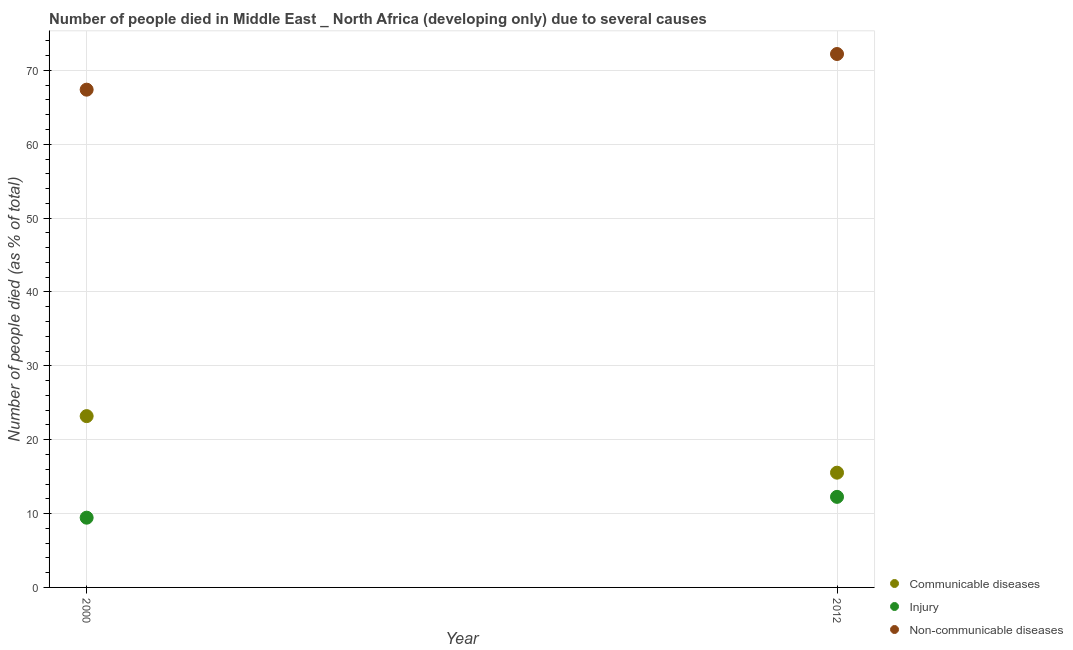How many different coloured dotlines are there?
Provide a short and direct response. 3. Is the number of dotlines equal to the number of legend labels?
Your response must be concise. Yes. What is the number of people who died of injury in 2000?
Provide a succinct answer. 9.44. Across all years, what is the maximum number of people who died of injury?
Ensure brevity in your answer.  12.26. Across all years, what is the minimum number of people who dies of non-communicable diseases?
Provide a short and direct response. 67.39. In which year was the number of people who dies of non-communicable diseases minimum?
Keep it short and to the point. 2000. What is the total number of people who died of communicable diseases in the graph?
Your response must be concise. 38.73. What is the difference between the number of people who dies of non-communicable diseases in 2000 and that in 2012?
Give a very brief answer. -4.83. What is the difference between the number of people who died of communicable diseases in 2012 and the number of people who dies of non-communicable diseases in 2000?
Give a very brief answer. -51.86. What is the average number of people who died of injury per year?
Ensure brevity in your answer.  10.85. In the year 2012, what is the difference between the number of people who dies of non-communicable diseases and number of people who died of injury?
Offer a very short reply. 59.96. In how many years, is the number of people who died of injury greater than 50 %?
Your response must be concise. 0. What is the ratio of the number of people who died of injury in 2000 to that in 2012?
Offer a very short reply. 0.77. Is it the case that in every year, the sum of the number of people who died of communicable diseases and number of people who died of injury is greater than the number of people who dies of non-communicable diseases?
Ensure brevity in your answer.  No. Does the number of people who dies of non-communicable diseases monotonically increase over the years?
Keep it short and to the point. Yes. Is the number of people who died of injury strictly less than the number of people who dies of non-communicable diseases over the years?
Provide a short and direct response. Yes. What is the difference between two consecutive major ticks on the Y-axis?
Offer a very short reply. 10. Does the graph contain any zero values?
Provide a short and direct response. No. Does the graph contain grids?
Keep it short and to the point. Yes. How many legend labels are there?
Provide a short and direct response. 3. What is the title of the graph?
Ensure brevity in your answer.  Number of people died in Middle East _ North Africa (developing only) due to several causes. Does "Agricultural Nitrous Oxide" appear as one of the legend labels in the graph?
Offer a terse response. No. What is the label or title of the Y-axis?
Your answer should be compact. Number of people died (as % of total). What is the Number of people died (as % of total) in Communicable diseases in 2000?
Keep it short and to the point. 23.19. What is the Number of people died (as % of total) in Injury in 2000?
Ensure brevity in your answer.  9.44. What is the Number of people died (as % of total) of Non-communicable diseases in 2000?
Provide a short and direct response. 67.39. What is the Number of people died (as % of total) in Communicable diseases in 2012?
Your answer should be compact. 15.54. What is the Number of people died (as % of total) in Injury in 2012?
Your answer should be compact. 12.26. What is the Number of people died (as % of total) of Non-communicable diseases in 2012?
Keep it short and to the point. 72.22. Across all years, what is the maximum Number of people died (as % of total) in Communicable diseases?
Offer a terse response. 23.19. Across all years, what is the maximum Number of people died (as % of total) in Injury?
Provide a succinct answer. 12.26. Across all years, what is the maximum Number of people died (as % of total) in Non-communicable diseases?
Your response must be concise. 72.22. Across all years, what is the minimum Number of people died (as % of total) of Communicable diseases?
Make the answer very short. 15.54. Across all years, what is the minimum Number of people died (as % of total) of Injury?
Offer a very short reply. 9.44. Across all years, what is the minimum Number of people died (as % of total) in Non-communicable diseases?
Provide a succinct answer. 67.39. What is the total Number of people died (as % of total) in Communicable diseases in the graph?
Give a very brief answer. 38.73. What is the total Number of people died (as % of total) in Injury in the graph?
Offer a very short reply. 21.7. What is the total Number of people died (as % of total) in Non-communicable diseases in the graph?
Your answer should be compact. 139.61. What is the difference between the Number of people died (as % of total) of Communicable diseases in 2000 and that in 2012?
Your answer should be compact. 7.66. What is the difference between the Number of people died (as % of total) in Injury in 2000 and that in 2012?
Ensure brevity in your answer.  -2.82. What is the difference between the Number of people died (as % of total) in Non-communicable diseases in 2000 and that in 2012?
Your response must be concise. -4.83. What is the difference between the Number of people died (as % of total) in Communicable diseases in 2000 and the Number of people died (as % of total) in Injury in 2012?
Your response must be concise. 10.93. What is the difference between the Number of people died (as % of total) of Communicable diseases in 2000 and the Number of people died (as % of total) of Non-communicable diseases in 2012?
Give a very brief answer. -49.03. What is the difference between the Number of people died (as % of total) in Injury in 2000 and the Number of people died (as % of total) in Non-communicable diseases in 2012?
Offer a terse response. -62.78. What is the average Number of people died (as % of total) of Communicable diseases per year?
Keep it short and to the point. 19.36. What is the average Number of people died (as % of total) in Injury per year?
Offer a very short reply. 10.85. What is the average Number of people died (as % of total) of Non-communicable diseases per year?
Make the answer very short. 69.8. In the year 2000, what is the difference between the Number of people died (as % of total) in Communicable diseases and Number of people died (as % of total) in Injury?
Ensure brevity in your answer.  13.75. In the year 2000, what is the difference between the Number of people died (as % of total) of Communicable diseases and Number of people died (as % of total) of Non-communicable diseases?
Give a very brief answer. -44.2. In the year 2000, what is the difference between the Number of people died (as % of total) of Injury and Number of people died (as % of total) of Non-communicable diseases?
Keep it short and to the point. -57.95. In the year 2012, what is the difference between the Number of people died (as % of total) in Communicable diseases and Number of people died (as % of total) in Injury?
Your answer should be very brief. 3.27. In the year 2012, what is the difference between the Number of people died (as % of total) in Communicable diseases and Number of people died (as % of total) in Non-communicable diseases?
Your response must be concise. -56.68. In the year 2012, what is the difference between the Number of people died (as % of total) in Injury and Number of people died (as % of total) in Non-communicable diseases?
Keep it short and to the point. -59.96. What is the ratio of the Number of people died (as % of total) in Communicable diseases in 2000 to that in 2012?
Your answer should be compact. 1.49. What is the ratio of the Number of people died (as % of total) in Injury in 2000 to that in 2012?
Give a very brief answer. 0.77. What is the ratio of the Number of people died (as % of total) of Non-communicable diseases in 2000 to that in 2012?
Your answer should be very brief. 0.93. What is the difference between the highest and the second highest Number of people died (as % of total) in Communicable diseases?
Keep it short and to the point. 7.66. What is the difference between the highest and the second highest Number of people died (as % of total) of Injury?
Your response must be concise. 2.82. What is the difference between the highest and the second highest Number of people died (as % of total) in Non-communicable diseases?
Your answer should be compact. 4.83. What is the difference between the highest and the lowest Number of people died (as % of total) in Communicable diseases?
Offer a terse response. 7.66. What is the difference between the highest and the lowest Number of people died (as % of total) of Injury?
Keep it short and to the point. 2.82. What is the difference between the highest and the lowest Number of people died (as % of total) of Non-communicable diseases?
Ensure brevity in your answer.  4.83. 